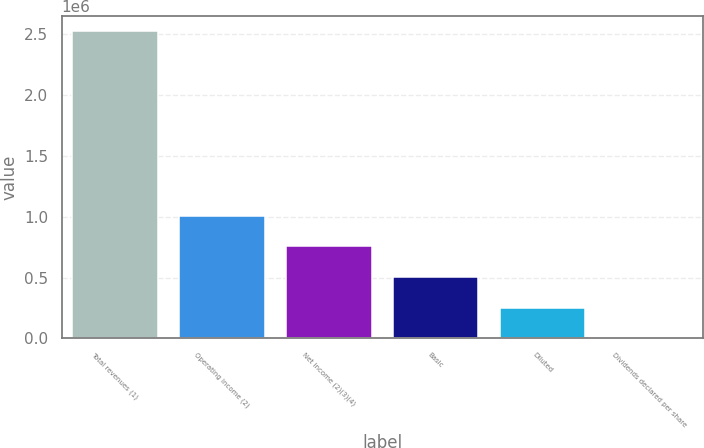<chart> <loc_0><loc_0><loc_500><loc_500><bar_chart><fcel>Total revenues (1)<fcel>Operating income (2)<fcel>Net income (2)(3)(4)<fcel>Basic<fcel>Diluted<fcel>Dividends declared per share<nl><fcel>2.5231e+06<fcel>1.00924e+06<fcel>756930<fcel>504620<fcel>252310<fcel>0.38<nl></chart> 